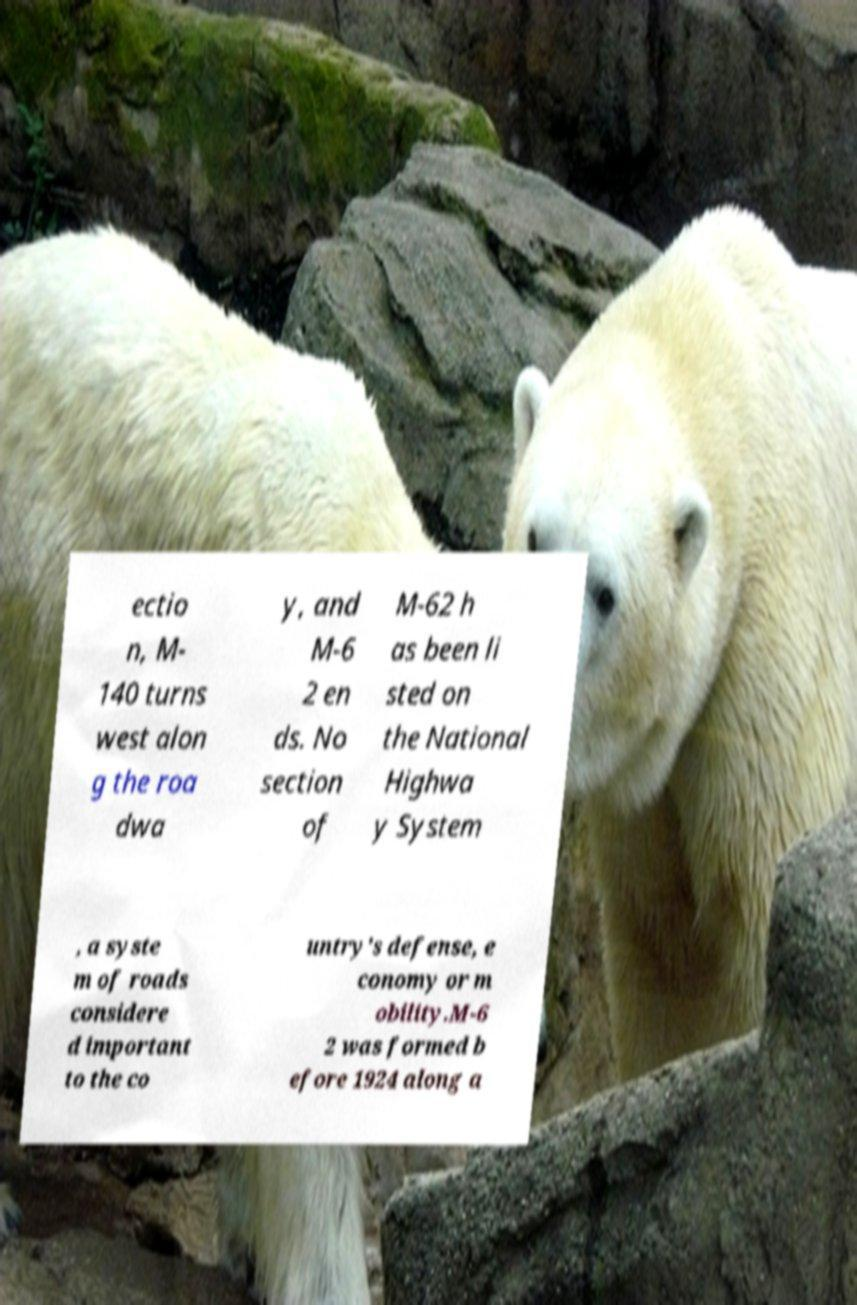Could you assist in decoding the text presented in this image and type it out clearly? ectio n, M- 140 turns west alon g the roa dwa y, and M-6 2 en ds. No section of M-62 h as been li sted on the National Highwa y System , a syste m of roads considere d important to the co untry's defense, e conomy or m obility.M-6 2 was formed b efore 1924 along a 